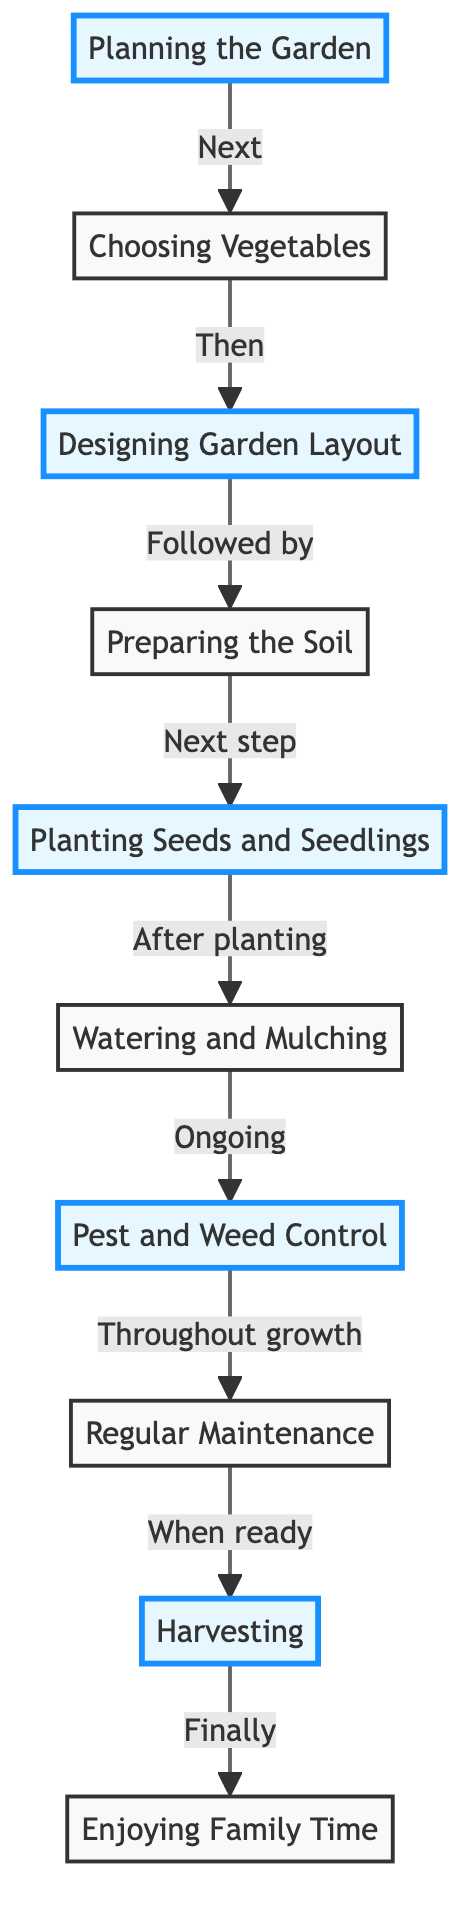What is the first step in setting up a home vegetable garden? The first step is indicated as "Planning the Garden," which involves selecting the garden location, considering sunlight, and preparing the soil.
Answer: Planning the Garden How many nodes are there in the diagram? By counting the different steps provided in the nodes, there are a total of 10 distinct steps in the diagram.
Answer: 10 What follows after "Choosing Vegetables"? The diagram indicates that "Designing Garden Layout" comes next after "Choosing Vegetables."
Answer: Designing Garden Layout Which step involves watering and applying mulch? The step that focuses on watering and applying mulch is titled "Watering and Mulching."
Answer: Watering and Mulching What is the final step shown in the diagram? The last step depicted is "Enjoying Family Time," which emphasizes engaging with kids in using the harvested vegetables.
Answer: Enjoying Family Time What is the relationship between "Preparing the Soil" and "Planting Seeds and Seedlings"? The relationship is sequential; "Preparing the Soil" is followed by "Planting Seeds and Seedlings," meaning soil preparation must occur before planting.
Answer: Next step Which two steps are involved directly in the maintenance of the garden? "Pest and Weed Control" and "Regular Maintenance" are the two steps that directly pertain to maintaining the health of the garden.
Answer: Pest and Weed Control, Regular Maintenance How does "Harvesting" relate to "Enjoying Family Time"? "Harvesting" is the step immediately before "Enjoying Family Time," indicating that harvesting leads to engaging with family.
Answer: Finally Which steps are highlighted in the diagram? The highlighted steps in the diagram are "Planning the Garden," "Designing Garden Layout," "Planting Seeds and Seedlings," "Pest and Weed Control," and "Harvesting."
Answer: Planning the Garden, Designing Garden Layout, Planting Seeds and Seedlings, Pest and Weed Control, Harvesting 